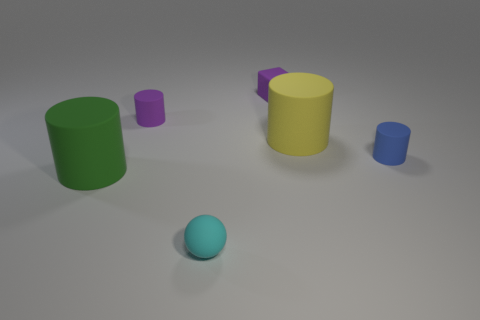There is a tiny matte cylinder that is behind the small blue cylinder; is its color the same as the small matte cube?
Make the answer very short. Yes. There is a tiny rubber thing that is in front of the large green matte cylinder in front of the small blue rubber thing; what number of large cylinders are left of it?
Provide a succinct answer. 1. How many rubber things are to the left of the tiny matte block and in front of the purple matte cylinder?
Offer a terse response. 2. What shape is the matte thing that is the same color as the block?
Provide a succinct answer. Cylinder. Is the material of the large green object the same as the purple cube?
Provide a succinct answer. Yes. What is the shape of the purple rubber object that is to the right of the small object on the left side of the thing that is in front of the big green object?
Your answer should be compact. Cube. Are there fewer blue rubber things that are left of the tiny purple matte cube than tiny cyan things that are behind the big green cylinder?
Provide a succinct answer. No. What shape is the tiny matte object that is right of the big matte cylinder on the right side of the cyan thing?
Make the answer very short. Cylinder. Is there anything else that has the same color as the small rubber ball?
Your answer should be very brief. No. Is the rubber block the same color as the matte sphere?
Ensure brevity in your answer.  No. 